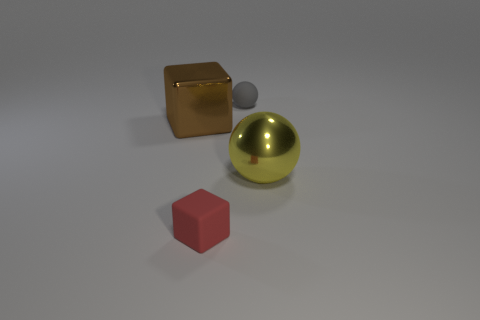Is there any other thing that is the same size as the yellow sphere?
Provide a short and direct response. Yes. There is a small object behind the small red object; is its shape the same as the large brown object?
Offer a very short reply. No. Is the number of tiny matte spheres that are in front of the large brown block greater than the number of green cubes?
Your answer should be very brief. No. The matte thing in front of the small thing that is behind the small red rubber block is what color?
Ensure brevity in your answer.  Red. How many yellow spheres are there?
Provide a short and direct response. 1. What number of things are both to the right of the gray sphere and in front of the big yellow shiny object?
Your answer should be compact. 0. Is there any other thing that is the same shape as the red object?
Offer a terse response. Yes. Does the small cube have the same color as the large object in front of the brown metallic block?
Make the answer very short. No. What is the shape of the big object to the right of the tiny red object?
Make the answer very short. Sphere. How many other objects are the same material as the small red block?
Keep it short and to the point. 1. 